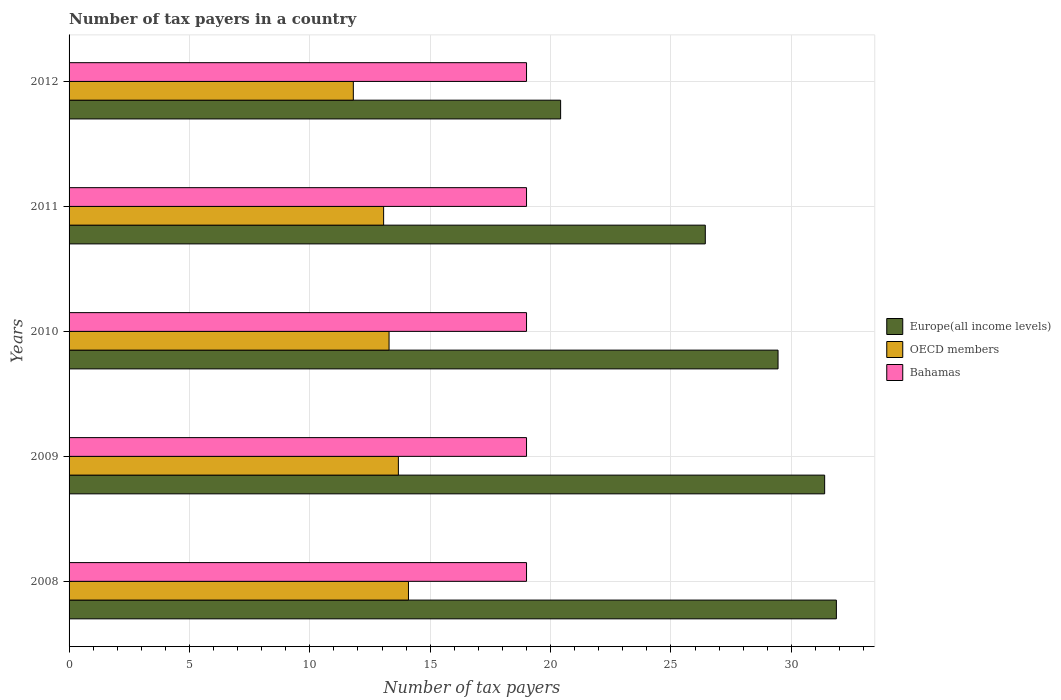Are the number of bars on each tick of the Y-axis equal?
Offer a very short reply. Yes. How many bars are there on the 3rd tick from the top?
Keep it short and to the point. 3. How many bars are there on the 1st tick from the bottom?
Your answer should be very brief. 3. In how many cases, is the number of bars for a given year not equal to the number of legend labels?
Offer a very short reply. 0. What is the number of tax payers in in OECD members in 2008?
Keep it short and to the point. 14.1. Across all years, what is the maximum number of tax payers in in OECD members?
Offer a terse response. 14.1. Across all years, what is the minimum number of tax payers in in Europe(all income levels)?
Offer a very short reply. 20.42. In which year was the number of tax payers in in Bahamas maximum?
Give a very brief answer. 2008. What is the total number of tax payers in in OECD members in the graph?
Provide a short and direct response. 65.94. What is the difference between the number of tax payers in in Bahamas in 2011 and that in 2012?
Make the answer very short. 0. What is the difference between the number of tax payers in in OECD members in 2010 and the number of tax payers in in Bahamas in 2008?
Give a very brief answer. -5.71. What is the average number of tax payers in in OECD members per year?
Offer a very short reply. 13.19. In the year 2009, what is the difference between the number of tax payers in in Europe(all income levels) and number of tax payers in in OECD members?
Provide a succinct answer. 17.71. In how many years, is the number of tax payers in in Europe(all income levels) greater than 19 ?
Ensure brevity in your answer.  5. What is the ratio of the number of tax payers in in Europe(all income levels) in 2010 to that in 2011?
Your response must be concise. 1.11. Is the sum of the number of tax payers in in Europe(all income levels) in 2008 and 2011 greater than the maximum number of tax payers in in OECD members across all years?
Your answer should be very brief. Yes. What does the 1st bar from the top in 2008 represents?
Your answer should be very brief. Bahamas. What does the 3rd bar from the bottom in 2009 represents?
Your response must be concise. Bahamas. How many bars are there?
Your response must be concise. 15. Are all the bars in the graph horizontal?
Make the answer very short. Yes. What is the difference between two consecutive major ticks on the X-axis?
Your answer should be compact. 5. Are the values on the major ticks of X-axis written in scientific E-notation?
Offer a terse response. No. Does the graph contain any zero values?
Your answer should be very brief. No. How are the legend labels stacked?
Keep it short and to the point. Vertical. What is the title of the graph?
Your response must be concise. Number of tax payers in a country. Does "Hungary" appear as one of the legend labels in the graph?
Provide a short and direct response. No. What is the label or title of the X-axis?
Your answer should be compact. Number of tax payers. What is the label or title of the Y-axis?
Offer a terse response. Years. What is the Number of tax payers in Europe(all income levels) in 2008?
Provide a succinct answer. 31.87. What is the Number of tax payers of OECD members in 2008?
Your answer should be compact. 14.1. What is the Number of tax payers of Europe(all income levels) in 2009?
Your answer should be very brief. 31.38. What is the Number of tax payers in OECD members in 2009?
Provide a succinct answer. 13.68. What is the Number of tax payers in Europe(all income levels) in 2010?
Provide a succinct answer. 29.45. What is the Number of tax payers in OECD members in 2010?
Your answer should be very brief. 13.29. What is the Number of tax payers of Europe(all income levels) in 2011?
Your answer should be very brief. 26.43. What is the Number of tax payers of OECD members in 2011?
Offer a very short reply. 13.06. What is the Number of tax payers in Europe(all income levels) in 2012?
Ensure brevity in your answer.  20.42. What is the Number of tax payers in OECD members in 2012?
Your answer should be very brief. 11.81. What is the Number of tax payers in Bahamas in 2012?
Offer a terse response. 19. Across all years, what is the maximum Number of tax payers in Europe(all income levels)?
Ensure brevity in your answer.  31.87. Across all years, what is the maximum Number of tax payers of OECD members?
Provide a short and direct response. 14.1. Across all years, what is the maximum Number of tax payers of Bahamas?
Provide a short and direct response. 19. Across all years, what is the minimum Number of tax payers of Europe(all income levels)?
Make the answer very short. 20.42. Across all years, what is the minimum Number of tax payers of OECD members?
Ensure brevity in your answer.  11.81. What is the total Number of tax payers of Europe(all income levels) in the graph?
Provide a short and direct response. 139.54. What is the total Number of tax payers in OECD members in the graph?
Your response must be concise. 65.94. What is the difference between the Number of tax payers in Europe(all income levels) in 2008 and that in 2009?
Provide a short and direct response. 0.49. What is the difference between the Number of tax payers of OECD members in 2008 and that in 2009?
Offer a terse response. 0.42. What is the difference between the Number of tax payers of Europe(all income levels) in 2008 and that in 2010?
Give a very brief answer. 2.42. What is the difference between the Number of tax payers in OECD members in 2008 and that in 2010?
Ensure brevity in your answer.  0.81. What is the difference between the Number of tax payers of Bahamas in 2008 and that in 2010?
Your response must be concise. 0. What is the difference between the Number of tax payers of Europe(all income levels) in 2008 and that in 2011?
Offer a very short reply. 5.44. What is the difference between the Number of tax payers in OECD members in 2008 and that in 2011?
Your answer should be very brief. 1.03. What is the difference between the Number of tax payers of Europe(all income levels) in 2008 and that in 2012?
Your response must be concise. 11.45. What is the difference between the Number of tax payers of OECD members in 2008 and that in 2012?
Your answer should be compact. 2.29. What is the difference between the Number of tax payers in Bahamas in 2008 and that in 2012?
Ensure brevity in your answer.  0. What is the difference between the Number of tax payers of Europe(all income levels) in 2009 and that in 2010?
Provide a short and direct response. 1.94. What is the difference between the Number of tax payers of OECD members in 2009 and that in 2010?
Your response must be concise. 0.39. What is the difference between the Number of tax payers in Bahamas in 2009 and that in 2010?
Provide a short and direct response. 0. What is the difference between the Number of tax payers in Europe(all income levels) in 2009 and that in 2011?
Make the answer very short. 4.96. What is the difference between the Number of tax payers of OECD members in 2009 and that in 2011?
Keep it short and to the point. 0.61. What is the difference between the Number of tax payers of Europe(all income levels) in 2009 and that in 2012?
Your answer should be very brief. 10.97. What is the difference between the Number of tax payers of OECD members in 2009 and that in 2012?
Make the answer very short. 1.87. What is the difference between the Number of tax payers in Europe(all income levels) in 2010 and that in 2011?
Provide a short and direct response. 3.02. What is the difference between the Number of tax payers in OECD members in 2010 and that in 2011?
Your answer should be very brief. 0.23. What is the difference between the Number of tax payers in Bahamas in 2010 and that in 2011?
Make the answer very short. 0. What is the difference between the Number of tax payers in Europe(all income levels) in 2010 and that in 2012?
Provide a succinct answer. 9.03. What is the difference between the Number of tax payers of OECD members in 2010 and that in 2012?
Provide a succinct answer. 1.48. What is the difference between the Number of tax payers of Europe(all income levels) in 2011 and that in 2012?
Keep it short and to the point. 6.01. What is the difference between the Number of tax payers of OECD members in 2011 and that in 2012?
Your answer should be very brief. 1.26. What is the difference between the Number of tax payers in Europe(all income levels) in 2008 and the Number of tax payers in OECD members in 2009?
Your answer should be very brief. 18.19. What is the difference between the Number of tax payers in Europe(all income levels) in 2008 and the Number of tax payers in Bahamas in 2009?
Offer a terse response. 12.87. What is the difference between the Number of tax payers of OECD members in 2008 and the Number of tax payers of Bahamas in 2009?
Your answer should be compact. -4.9. What is the difference between the Number of tax payers of Europe(all income levels) in 2008 and the Number of tax payers of OECD members in 2010?
Offer a very short reply. 18.58. What is the difference between the Number of tax payers in Europe(all income levels) in 2008 and the Number of tax payers in Bahamas in 2010?
Offer a very short reply. 12.87. What is the difference between the Number of tax payers in OECD members in 2008 and the Number of tax payers in Bahamas in 2010?
Provide a short and direct response. -4.9. What is the difference between the Number of tax payers in Europe(all income levels) in 2008 and the Number of tax payers in OECD members in 2011?
Offer a terse response. 18.8. What is the difference between the Number of tax payers of Europe(all income levels) in 2008 and the Number of tax payers of Bahamas in 2011?
Provide a short and direct response. 12.87. What is the difference between the Number of tax payers of OECD members in 2008 and the Number of tax payers of Bahamas in 2011?
Provide a short and direct response. -4.9. What is the difference between the Number of tax payers of Europe(all income levels) in 2008 and the Number of tax payers of OECD members in 2012?
Keep it short and to the point. 20.06. What is the difference between the Number of tax payers in Europe(all income levels) in 2008 and the Number of tax payers in Bahamas in 2012?
Ensure brevity in your answer.  12.87. What is the difference between the Number of tax payers in OECD members in 2008 and the Number of tax payers in Bahamas in 2012?
Your answer should be compact. -4.9. What is the difference between the Number of tax payers in Europe(all income levels) in 2009 and the Number of tax payers in OECD members in 2010?
Ensure brevity in your answer.  18.09. What is the difference between the Number of tax payers in Europe(all income levels) in 2009 and the Number of tax payers in Bahamas in 2010?
Your answer should be very brief. 12.38. What is the difference between the Number of tax payers of OECD members in 2009 and the Number of tax payers of Bahamas in 2010?
Your answer should be very brief. -5.32. What is the difference between the Number of tax payers in Europe(all income levels) in 2009 and the Number of tax payers in OECD members in 2011?
Keep it short and to the point. 18.32. What is the difference between the Number of tax payers of Europe(all income levels) in 2009 and the Number of tax payers of Bahamas in 2011?
Provide a short and direct response. 12.38. What is the difference between the Number of tax payers of OECD members in 2009 and the Number of tax payers of Bahamas in 2011?
Provide a short and direct response. -5.32. What is the difference between the Number of tax payers in Europe(all income levels) in 2009 and the Number of tax payers in OECD members in 2012?
Offer a very short reply. 19.58. What is the difference between the Number of tax payers of Europe(all income levels) in 2009 and the Number of tax payers of Bahamas in 2012?
Keep it short and to the point. 12.38. What is the difference between the Number of tax payers in OECD members in 2009 and the Number of tax payers in Bahamas in 2012?
Offer a very short reply. -5.32. What is the difference between the Number of tax payers of Europe(all income levels) in 2010 and the Number of tax payers of OECD members in 2011?
Your answer should be compact. 16.38. What is the difference between the Number of tax payers of Europe(all income levels) in 2010 and the Number of tax payers of Bahamas in 2011?
Ensure brevity in your answer.  10.45. What is the difference between the Number of tax payers of OECD members in 2010 and the Number of tax payers of Bahamas in 2011?
Provide a short and direct response. -5.71. What is the difference between the Number of tax payers of Europe(all income levels) in 2010 and the Number of tax payers of OECD members in 2012?
Offer a terse response. 17.64. What is the difference between the Number of tax payers of Europe(all income levels) in 2010 and the Number of tax payers of Bahamas in 2012?
Make the answer very short. 10.45. What is the difference between the Number of tax payers of OECD members in 2010 and the Number of tax payers of Bahamas in 2012?
Give a very brief answer. -5.71. What is the difference between the Number of tax payers of Europe(all income levels) in 2011 and the Number of tax payers of OECD members in 2012?
Keep it short and to the point. 14.62. What is the difference between the Number of tax payers of Europe(all income levels) in 2011 and the Number of tax payers of Bahamas in 2012?
Provide a succinct answer. 7.43. What is the difference between the Number of tax payers of OECD members in 2011 and the Number of tax payers of Bahamas in 2012?
Provide a short and direct response. -5.94. What is the average Number of tax payers of Europe(all income levels) per year?
Your response must be concise. 27.91. What is the average Number of tax payers in OECD members per year?
Offer a terse response. 13.19. In the year 2008, what is the difference between the Number of tax payers in Europe(all income levels) and Number of tax payers in OECD members?
Your answer should be compact. 17.77. In the year 2008, what is the difference between the Number of tax payers in Europe(all income levels) and Number of tax payers in Bahamas?
Make the answer very short. 12.87. In the year 2008, what is the difference between the Number of tax payers of OECD members and Number of tax payers of Bahamas?
Your answer should be compact. -4.9. In the year 2009, what is the difference between the Number of tax payers of Europe(all income levels) and Number of tax payers of OECD members?
Make the answer very short. 17.71. In the year 2009, what is the difference between the Number of tax payers of Europe(all income levels) and Number of tax payers of Bahamas?
Provide a short and direct response. 12.38. In the year 2009, what is the difference between the Number of tax payers in OECD members and Number of tax payers in Bahamas?
Offer a very short reply. -5.32. In the year 2010, what is the difference between the Number of tax payers of Europe(all income levels) and Number of tax payers of OECD members?
Ensure brevity in your answer.  16.16. In the year 2010, what is the difference between the Number of tax payers in Europe(all income levels) and Number of tax payers in Bahamas?
Your response must be concise. 10.45. In the year 2010, what is the difference between the Number of tax payers of OECD members and Number of tax payers of Bahamas?
Provide a succinct answer. -5.71. In the year 2011, what is the difference between the Number of tax payers in Europe(all income levels) and Number of tax payers in OECD members?
Offer a terse response. 13.36. In the year 2011, what is the difference between the Number of tax payers of Europe(all income levels) and Number of tax payers of Bahamas?
Offer a very short reply. 7.43. In the year 2011, what is the difference between the Number of tax payers of OECD members and Number of tax payers of Bahamas?
Give a very brief answer. -5.94. In the year 2012, what is the difference between the Number of tax payers of Europe(all income levels) and Number of tax payers of OECD members?
Your response must be concise. 8.61. In the year 2012, what is the difference between the Number of tax payers in Europe(all income levels) and Number of tax payers in Bahamas?
Make the answer very short. 1.42. In the year 2012, what is the difference between the Number of tax payers in OECD members and Number of tax payers in Bahamas?
Your answer should be very brief. -7.19. What is the ratio of the Number of tax payers in Europe(all income levels) in 2008 to that in 2009?
Give a very brief answer. 1.02. What is the ratio of the Number of tax payers in OECD members in 2008 to that in 2009?
Make the answer very short. 1.03. What is the ratio of the Number of tax payers in Bahamas in 2008 to that in 2009?
Your answer should be compact. 1. What is the ratio of the Number of tax payers of Europe(all income levels) in 2008 to that in 2010?
Provide a succinct answer. 1.08. What is the ratio of the Number of tax payers in OECD members in 2008 to that in 2010?
Offer a very short reply. 1.06. What is the ratio of the Number of tax payers in Bahamas in 2008 to that in 2010?
Provide a succinct answer. 1. What is the ratio of the Number of tax payers of Europe(all income levels) in 2008 to that in 2011?
Give a very brief answer. 1.21. What is the ratio of the Number of tax payers of OECD members in 2008 to that in 2011?
Your response must be concise. 1.08. What is the ratio of the Number of tax payers in Bahamas in 2008 to that in 2011?
Make the answer very short. 1. What is the ratio of the Number of tax payers in Europe(all income levels) in 2008 to that in 2012?
Ensure brevity in your answer.  1.56. What is the ratio of the Number of tax payers in OECD members in 2008 to that in 2012?
Make the answer very short. 1.19. What is the ratio of the Number of tax payers in Bahamas in 2008 to that in 2012?
Provide a short and direct response. 1. What is the ratio of the Number of tax payers in Europe(all income levels) in 2009 to that in 2010?
Provide a succinct answer. 1.07. What is the ratio of the Number of tax payers in OECD members in 2009 to that in 2010?
Ensure brevity in your answer.  1.03. What is the ratio of the Number of tax payers in Europe(all income levels) in 2009 to that in 2011?
Your answer should be very brief. 1.19. What is the ratio of the Number of tax payers in OECD members in 2009 to that in 2011?
Make the answer very short. 1.05. What is the ratio of the Number of tax payers of Europe(all income levels) in 2009 to that in 2012?
Offer a terse response. 1.54. What is the ratio of the Number of tax payers in OECD members in 2009 to that in 2012?
Your response must be concise. 1.16. What is the ratio of the Number of tax payers in Bahamas in 2009 to that in 2012?
Offer a very short reply. 1. What is the ratio of the Number of tax payers of Europe(all income levels) in 2010 to that in 2011?
Make the answer very short. 1.11. What is the ratio of the Number of tax payers in OECD members in 2010 to that in 2011?
Make the answer very short. 1.02. What is the ratio of the Number of tax payers in Bahamas in 2010 to that in 2011?
Give a very brief answer. 1. What is the ratio of the Number of tax payers of Europe(all income levels) in 2010 to that in 2012?
Ensure brevity in your answer.  1.44. What is the ratio of the Number of tax payers in OECD members in 2010 to that in 2012?
Your response must be concise. 1.13. What is the ratio of the Number of tax payers of Bahamas in 2010 to that in 2012?
Your answer should be very brief. 1. What is the ratio of the Number of tax payers of Europe(all income levels) in 2011 to that in 2012?
Your answer should be very brief. 1.29. What is the ratio of the Number of tax payers in OECD members in 2011 to that in 2012?
Give a very brief answer. 1.11. What is the difference between the highest and the second highest Number of tax payers in Europe(all income levels)?
Offer a terse response. 0.49. What is the difference between the highest and the second highest Number of tax payers in OECD members?
Provide a succinct answer. 0.42. What is the difference between the highest and the lowest Number of tax payers of Europe(all income levels)?
Give a very brief answer. 11.45. What is the difference between the highest and the lowest Number of tax payers in OECD members?
Give a very brief answer. 2.29. What is the difference between the highest and the lowest Number of tax payers of Bahamas?
Offer a very short reply. 0. 